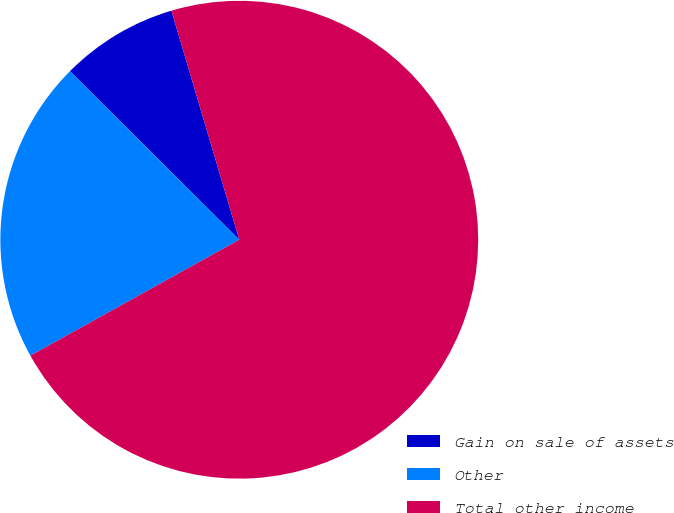Convert chart to OTSL. <chart><loc_0><loc_0><loc_500><loc_500><pie_chart><fcel>Gain on sale of assets<fcel>Other<fcel>Total other income<nl><fcel>7.95%<fcel>20.53%<fcel>71.52%<nl></chart> 